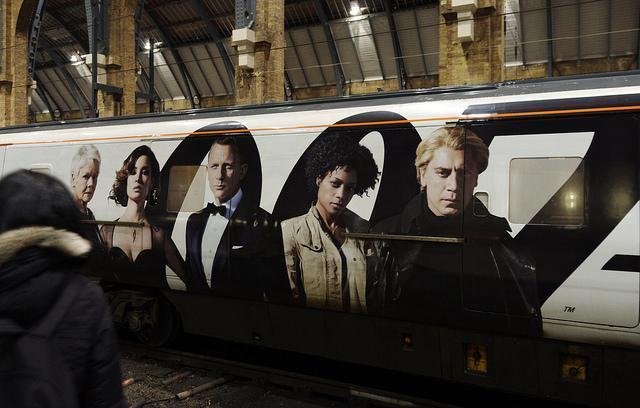How many people are there?
Give a very brief answer. 5. 